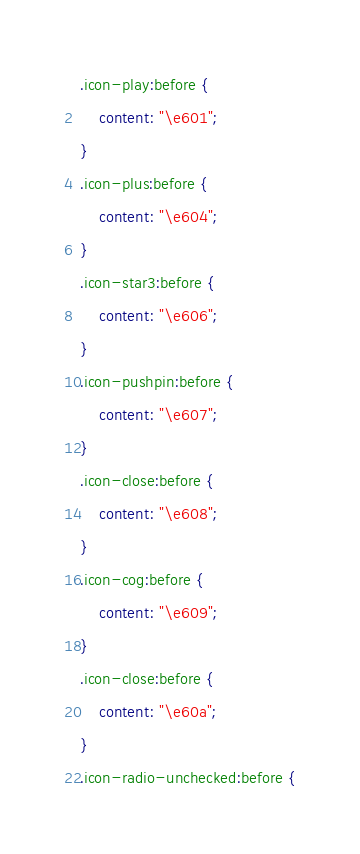<code> <loc_0><loc_0><loc_500><loc_500><_CSS_>.icon-play:before {
	content: "\e601";
}
.icon-plus:before {
	content: "\e604";
}
.icon-star3:before {
	content: "\e606";
}
.icon-pushpin:before {
	content: "\e607";
}
.icon-close:before {
	content: "\e608";
}
.icon-cog:before {
	content: "\e609";
}
.icon-close:before {
	content: "\e60a";
}
.icon-radio-unchecked:before {</code> 